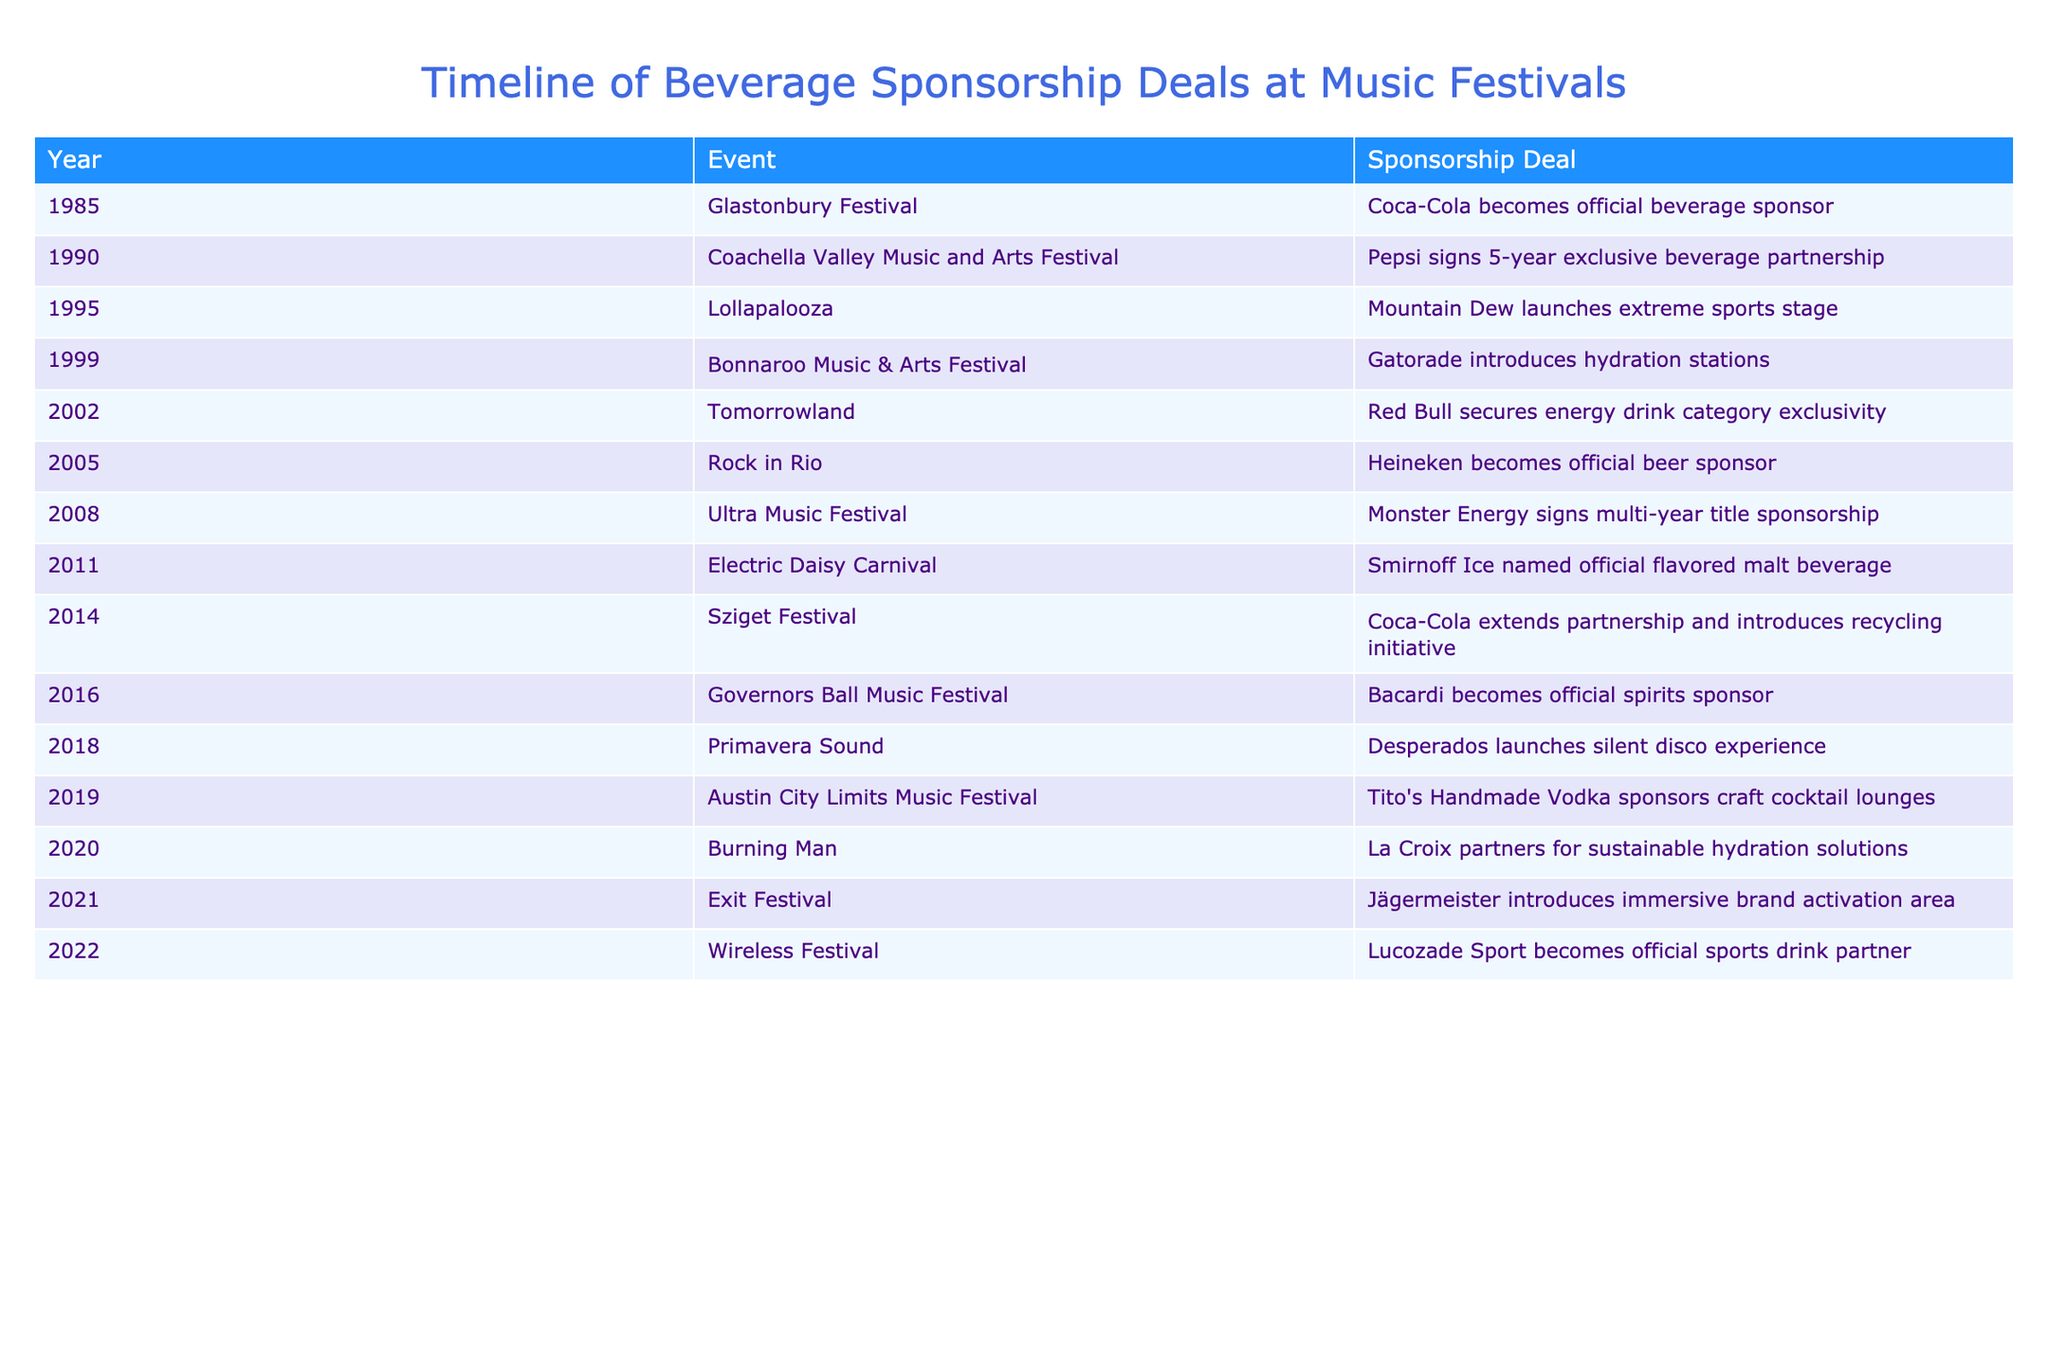What year did Coca-Cola become an official beverage sponsor at the Glastonbury Festival? The table shows that Coca-Cola became the official beverage sponsor of the Glastonbury Festival in the year 1985, as listed in the "Year" column corresponding to the event.
Answer: 1985 Which beverage brand secured energy drink category exclusivity in 2002? According to the table, Red Bull is mentioned as securing energy drink category exclusivity at Tomorrowland in the year 2002.
Answer: Red Bull How many years did Pepsi's exclusive beverage partnership at Coachella last? The table indicates that Pepsi signed a 5-year exclusive beverage partnership in 1990, making it straightforward to identify the duration as stated.
Answer: 5 years Was Heineken involved in any sponsorship deals before 2010? By examining the years listed in the table, Heineken became the official beer sponsor at Rock in Rio in 2005, which is before 2010, indicating that Heineken was indeed involved in sponsorship deals prior to that year.
Answer: Yes Which two brands introduced initiatives related to sustainability or recycling, based on the information in the table? The table shows that Coca-Cola extended its partnership to introduce a recycling initiative in 2014, and La Croix partnered for sustainable hydration solutions in 2020. These two brands focused on sustainability-related initiatives based on their sponsorship deals.
Answer: Coca-Cola and La Croix What is the most recent year listed in the table, and which event did that sponsorship deal involve? The latest year provided in the table is 2022, where Lucozade Sport became the official sports drink partner at the Wireless Festival, indicating the recency of this sponsorship deal.
Answer: 2022, Wireless Festival Count the total number of distinct beverage brands mentioned in the table. By analyzing the table, the distinct beverage brands are Coca-Cola, Pepsi, Mountain Dew, Gatorade, Red Bull, Heineken, Monster Energy, Smirnoff Ice, Bacardi, Desperados, Tito's Handmade Vodka, La Croix, and Jägermeister, totaling 13 unique brands.
Answer: 13 What was the main trend observed in sponsorship deals from the 1980s to 2020 in the table? Reviewing the timeline, there is a notable trend of increasing diversity in beverage sponsorships, with brands engaging in unique experiences (like silent disco) and sustainability initiatives, reflecting evolving marketing strategies and consumer preferences over the decades.
Answer: Increasing diversity and sustainability focus in sponsorships 